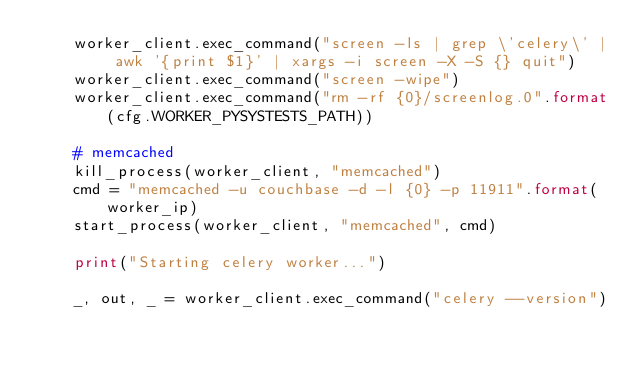<code> <loc_0><loc_0><loc_500><loc_500><_Python_>    worker_client.exec_command("screen -ls | grep \'celery\' | awk '{print $1}' | xargs -i screen -X -S {} quit")
    worker_client.exec_command("screen -wipe")
    worker_client.exec_command("rm -rf {0}/screenlog.0".format(cfg.WORKER_PYSYSTESTS_PATH))

    # memcached
    kill_process(worker_client, "memcached")
    cmd = "memcached -u couchbase -d -l {0} -p 11911".format(worker_ip)
    start_process(worker_client, "memcached", cmd)

    print("Starting celery worker...")

    _, out, _ = worker_client.exec_command("celery --version")</code> 